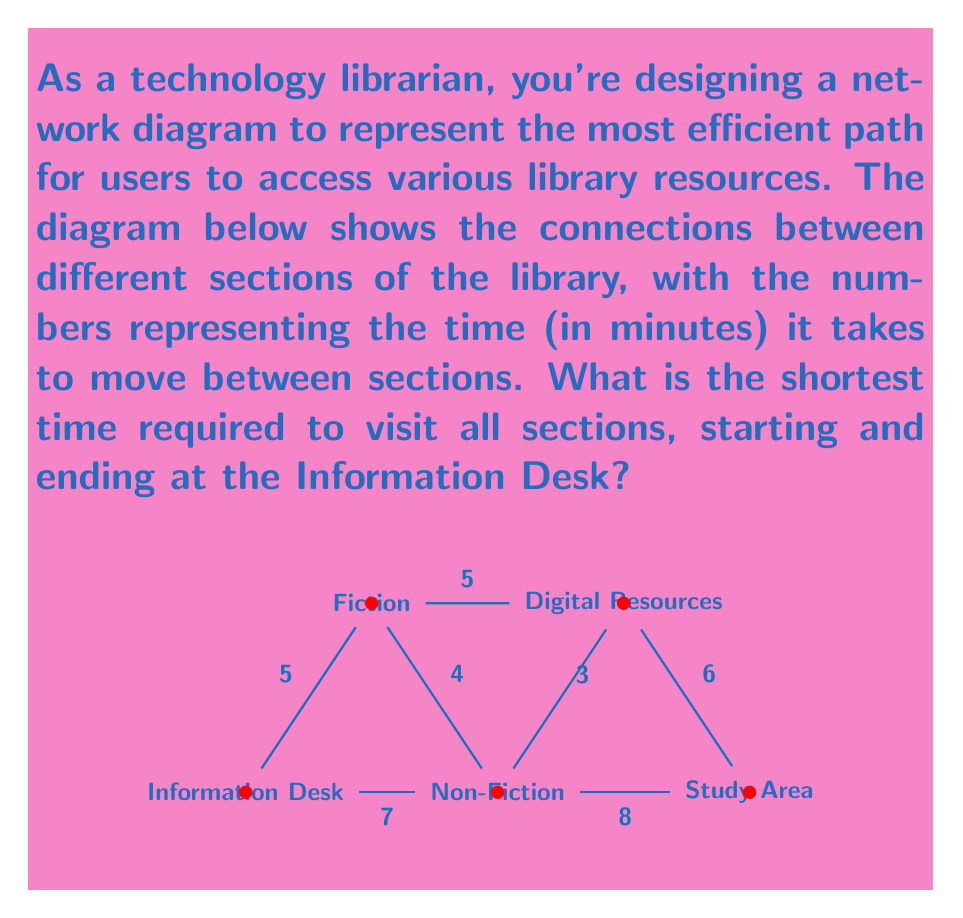Can you solve this math problem? To solve this problem, we need to find the shortest path that visits all sections of the library. We'll use the following approach:

1) First, list all possible paths that visit all sections:
   Path 1: Information Desk → Fiction → Non-Fiction → Digital Resources → Study Area
   Path 2: Information Desk → Fiction → Digital Resources → Non-Fiction → Study Area
   Path 3: Information Desk → Non-Fiction → Fiction → Digital Resources → Study Area
   Path 4: Information Desk → Non-Fiction → Digital Resources → Fiction → Study Area

2) Calculate the total time for each path:

   Path 1: 
   $5 + 4 + 3 + 6 = 18$ minutes

   Path 2: 
   $5 + 5 + 3 + 6 = 19$ minutes

   Path 3: 
   $7 + 4 + 5 + 6 = 22$ minutes

   Path 4: 
   $7 + 3 + 5 + 5 = 20$ minutes

3) Compare the total times:
   The shortest path is Path 1, which takes 18 minutes.

4) Therefore, the optimal route is:
   Information Desk → Fiction → Non-Fiction → Digital Resources → Study Area

This path ensures that all sections are visited in the shortest possible time, maximizing efficiency for library users.
Answer: 18 minutes 